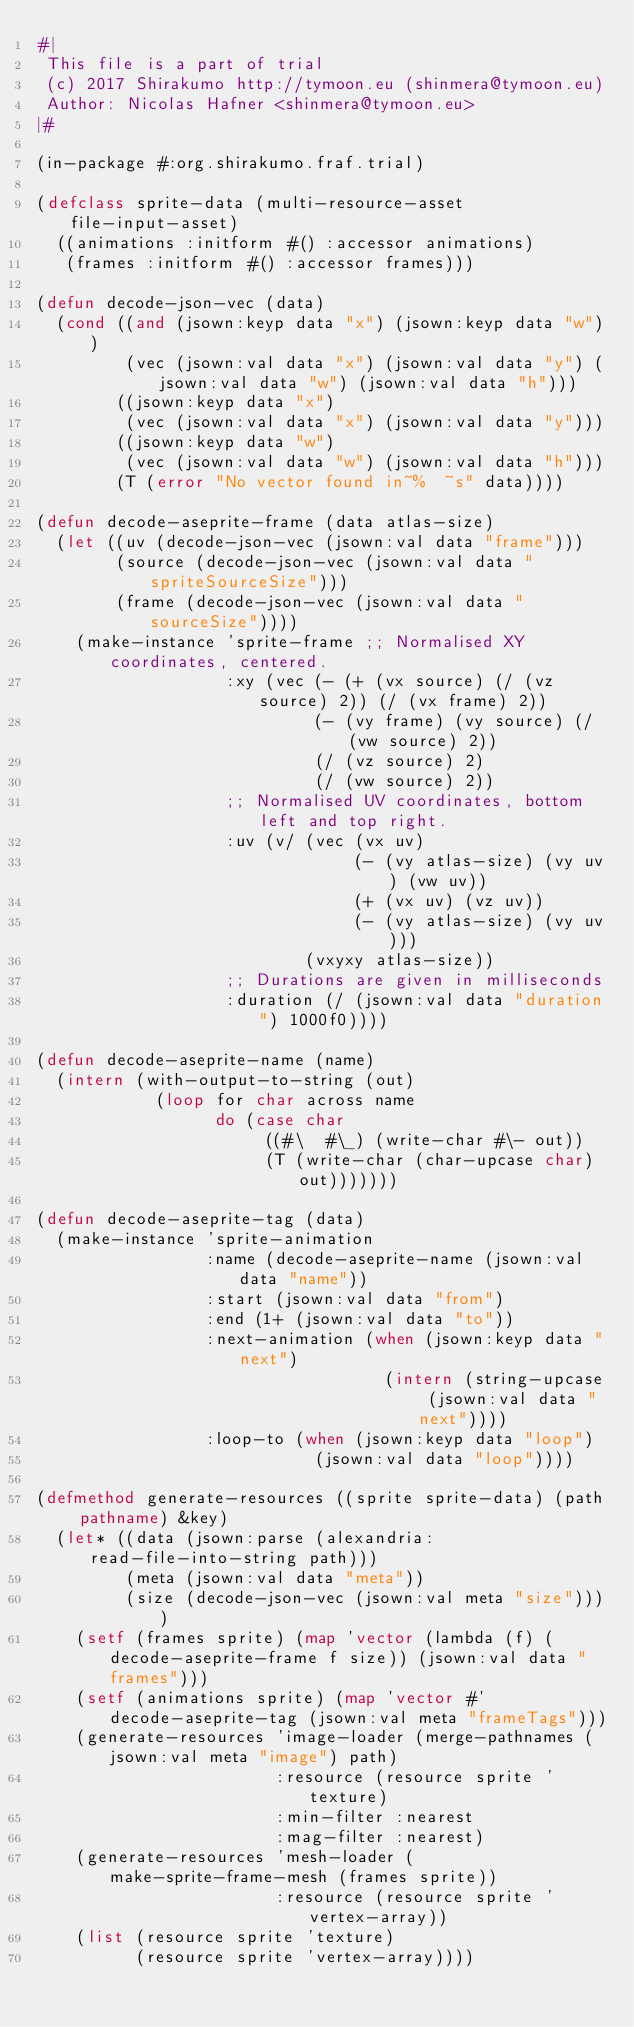<code> <loc_0><loc_0><loc_500><loc_500><_Lisp_>#|
 This file is a part of trial
 (c) 2017 Shirakumo http://tymoon.eu (shinmera@tymoon.eu)
 Author: Nicolas Hafner <shinmera@tymoon.eu>
|#

(in-package #:org.shirakumo.fraf.trial)

(defclass sprite-data (multi-resource-asset file-input-asset)
  ((animations :initform #() :accessor animations)
   (frames :initform #() :accessor frames)))

(defun decode-json-vec (data)
  (cond ((and (jsown:keyp data "x") (jsown:keyp data "w"))
         (vec (jsown:val data "x") (jsown:val data "y") (jsown:val data "w") (jsown:val data "h")))
        ((jsown:keyp data "x")
         (vec (jsown:val data "x") (jsown:val data "y")))
        ((jsown:keyp data "w")
         (vec (jsown:val data "w") (jsown:val data "h")))
        (T (error "No vector found in~%  ~s" data))))

(defun decode-aseprite-frame (data atlas-size)
  (let ((uv (decode-json-vec (jsown:val data "frame")))
        (source (decode-json-vec (jsown:val data "spriteSourceSize")))
        (frame (decode-json-vec (jsown:val data "sourceSize"))))
    (make-instance 'sprite-frame ;; Normalised XY coordinates, centered.
                   :xy (vec (- (+ (vx source) (/ (vz source) 2)) (/ (vx frame) 2))
                            (- (vy frame) (vy source) (/ (vw source) 2))
                            (/ (vz source) 2)
                            (/ (vw source) 2))
                   ;; Normalised UV coordinates, bottom left and top right.
                   :uv (v/ (vec (vx uv)
                                (- (vy atlas-size) (vy uv) (vw uv))
                                (+ (vx uv) (vz uv))
                                (- (vy atlas-size) (vy uv)))
                           (vxyxy atlas-size))
                   ;; Durations are given in milliseconds
                   :duration (/ (jsown:val data "duration") 1000f0))))

(defun decode-aseprite-name (name)
  (intern (with-output-to-string (out)
            (loop for char across name
                  do (case char
                       ((#\  #\_) (write-char #\- out))
                       (T (write-char (char-upcase char) out)))))))

(defun decode-aseprite-tag (data)
  (make-instance 'sprite-animation
                 :name (decode-aseprite-name (jsown:val data "name"))
                 :start (jsown:val data "from")
                 :end (1+ (jsown:val data "to"))
                 :next-animation (when (jsown:keyp data "next")
                                   (intern (string-upcase (jsown:val data "next"))))
                 :loop-to (when (jsown:keyp data "loop")
                            (jsown:val data "loop"))))

(defmethod generate-resources ((sprite sprite-data) (path pathname) &key)
  (let* ((data (jsown:parse (alexandria:read-file-into-string path)))
         (meta (jsown:val data "meta"))
         (size (decode-json-vec (jsown:val meta "size"))))
    (setf (frames sprite) (map 'vector (lambda (f) (decode-aseprite-frame f size)) (jsown:val data "frames")))
    (setf (animations sprite) (map 'vector #'decode-aseprite-tag (jsown:val meta "frameTags")))
    (generate-resources 'image-loader (merge-pathnames (jsown:val meta "image") path)
                        :resource (resource sprite 'texture)
                        :min-filter :nearest
                        :mag-filter :nearest)
    (generate-resources 'mesh-loader (make-sprite-frame-mesh (frames sprite))
                        :resource (resource sprite 'vertex-array))
    (list (resource sprite 'texture)
          (resource sprite 'vertex-array))))
</code> 